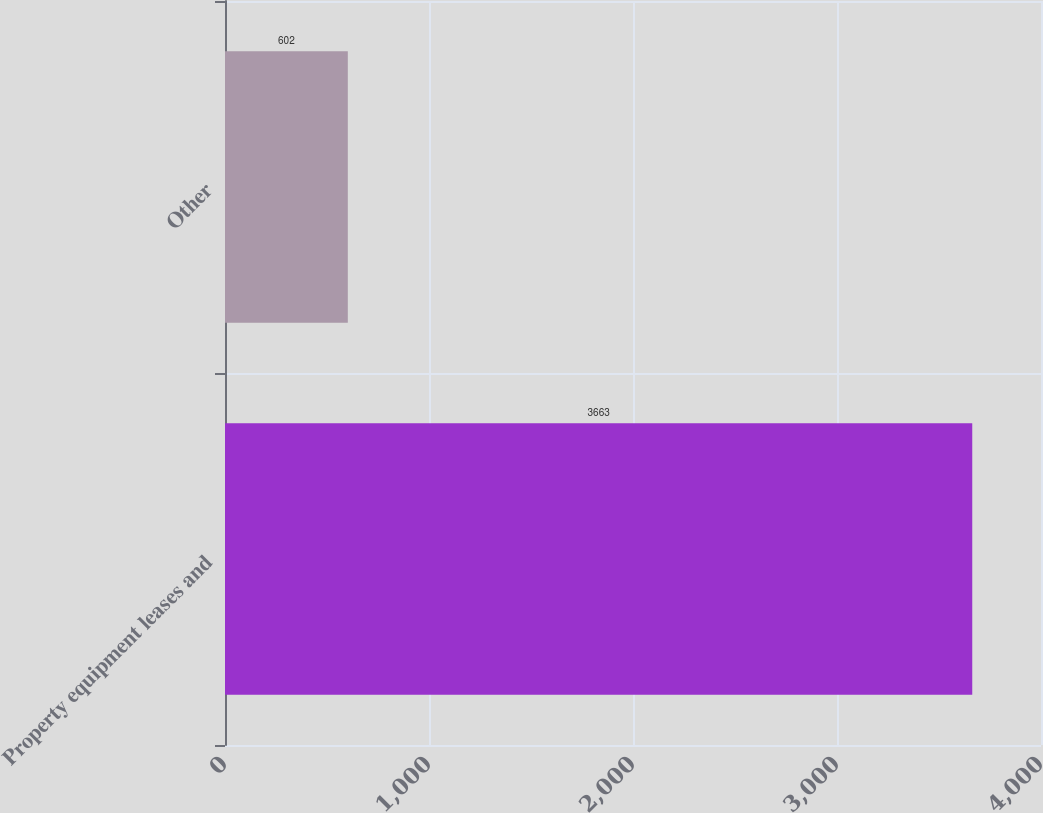Convert chart to OTSL. <chart><loc_0><loc_0><loc_500><loc_500><bar_chart><fcel>Property equipment leases and<fcel>Other<nl><fcel>3663<fcel>602<nl></chart> 